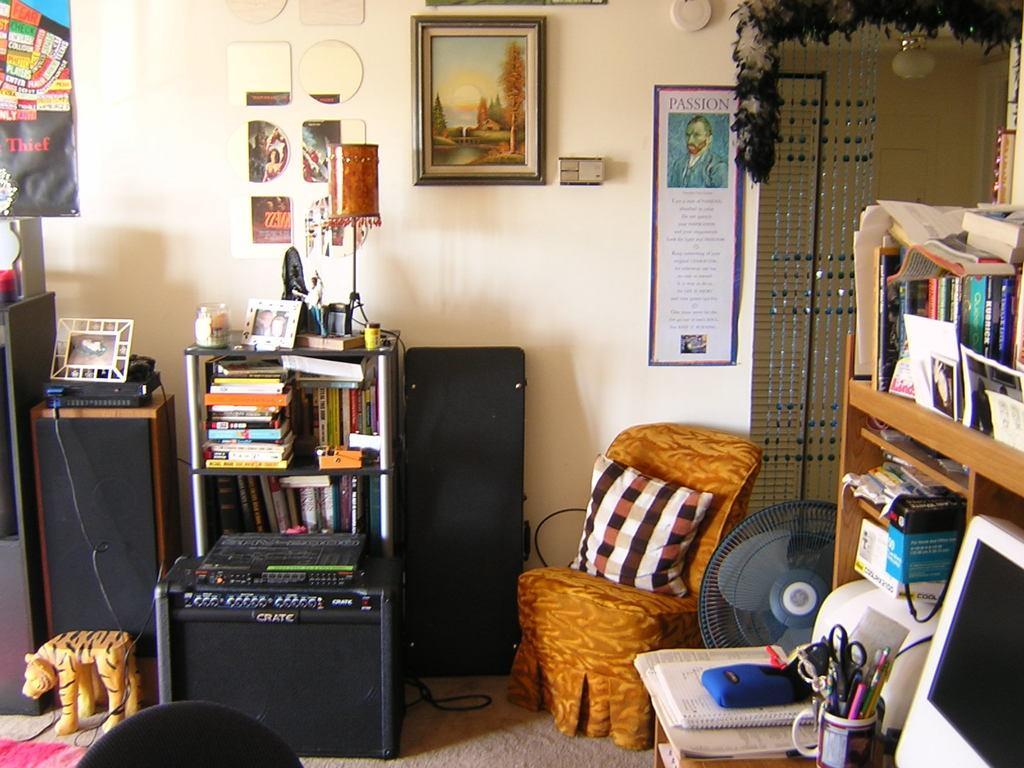Can you describe this image briefly? In this image there is a chair on the floor. There is a cushion on the chair. Beside there is a fan. Right side there is a rack having monitor, books, cup and few objects. In the cup there is a scissor, pens and few objects. Left side there is a toy on the floor. Behind there is a table having a device and a frame on it. Beside there is a rack having books, picture frames and few objects. There is a lamp on the rack. There is a device on the floor. There are posters and picture frames attached to the wall. 